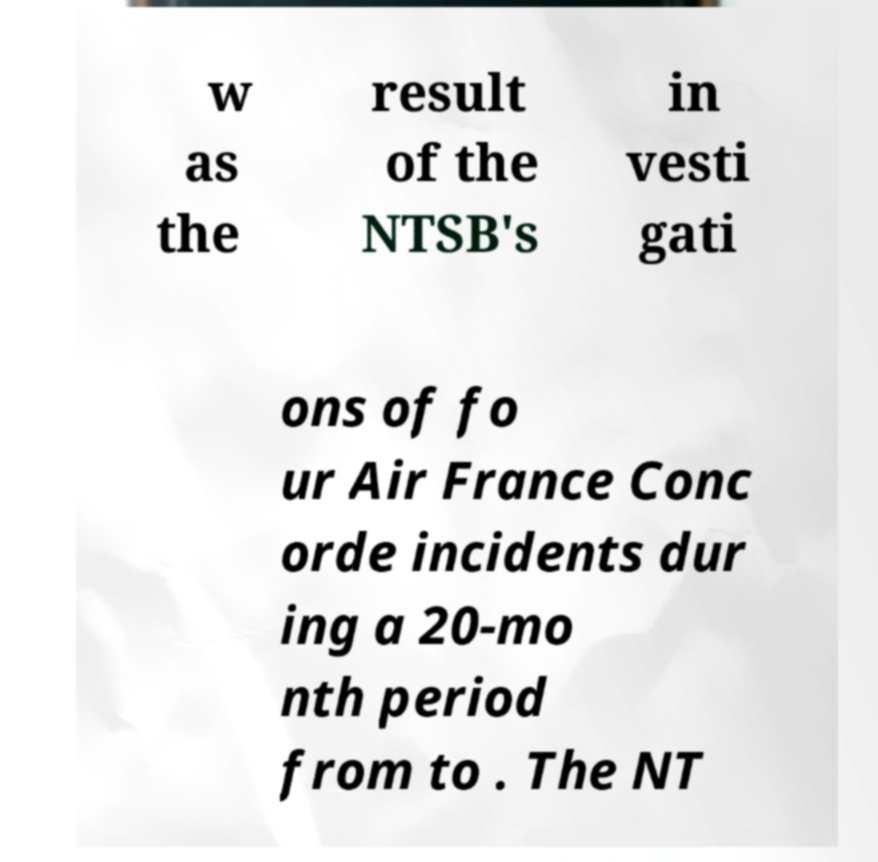Could you assist in decoding the text presented in this image and type it out clearly? w as the result of the NTSB's in vesti gati ons of fo ur Air France Conc orde incidents dur ing a 20-mo nth period from to . The NT 